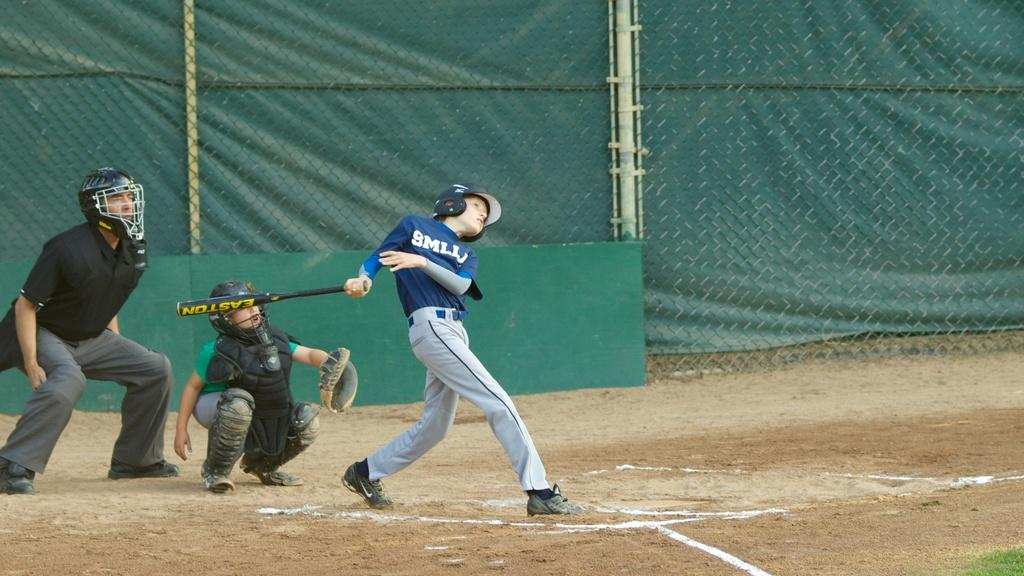<image>
Present a compact description of the photo's key features. the letter m is on the jersey of the person 